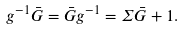<formula> <loc_0><loc_0><loc_500><loc_500>g ^ { - 1 } \bar { G } = \bar { G } g ^ { - 1 } = \Sigma \bar { G } + 1 .</formula> 